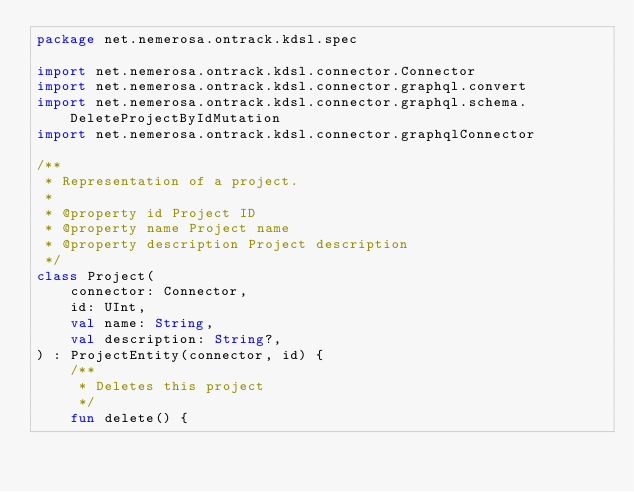Convert code to text. <code><loc_0><loc_0><loc_500><loc_500><_Kotlin_>package net.nemerosa.ontrack.kdsl.spec

import net.nemerosa.ontrack.kdsl.connector.Connector
import net.nemerosa.ontrack.kdsl.connector.graphql.convert
import net.nemerosa.ontrack.kdsl.connector.graphql.schema.DeleteProjectByIdMutation
import net.nemerosa.ontrack.kdsl.connector.graphqlConnector

/**
 * Representation of a project.
 *
 * @property id Project ID
 * @property name Project name
 * @property description Project description
 */
class Project(
    connector: Connector,
    id: UInt,
    val name: String,
    val description: String?,
) : ProjectEntity(connector, id) {
    /**
     * Deletes this project
     */
    fun delete() {</code> 